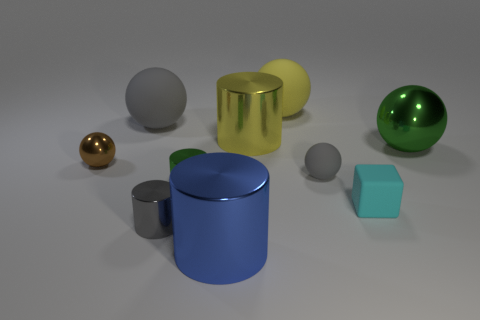What shapes are present among the objects in the image? In the image, we see a collection of geometric shapes. There's a cylindrical shape, a spherical shape in a couple of different sizes, and a cube. The objects present an interesting array of basic three-dimensional forms. 